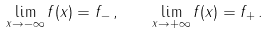<formula> <loc_0><loc_0><loc_500><loc_500>\lim _ { x \to - \infty } f ( x ) = f _ { - } \, , \quad \lim _ { x \to + \infty } f ( x ) = f _ { + } \, .</formula> 